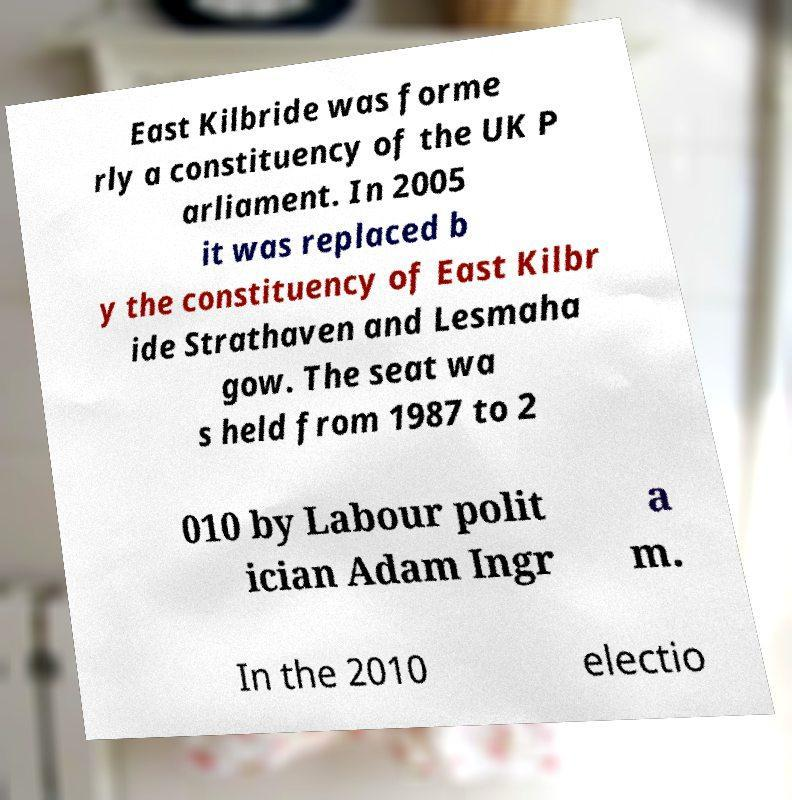I need the written content from this picture converted into text. Can you do that? East Kilbride was forme rly a constituency of the UK P arliament. In 2005 it was replaced b y the constituency of East Kilbr ide Strathaven and Lesmaha gow. The seat wa s held from 1987 to 2 010 by Labour polit ician Adam Ingr a m. In the 2010 electio 